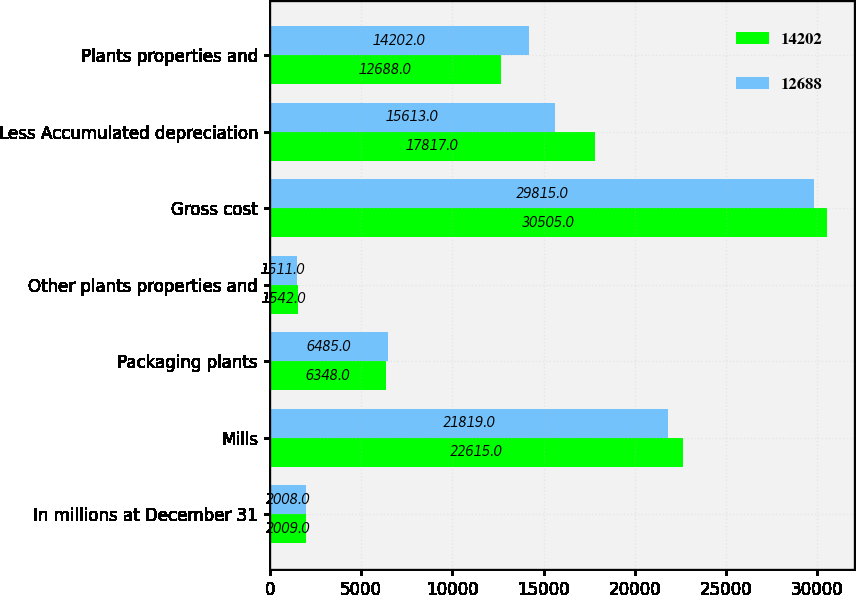Convert chart. <chart><loc_0><loc_0><loc_500><loc_500><stacked_bar_chart><ecel><fcel>In millions at December 31<fcel>Mills<fcel>Packaging plants<fcel>Other plants properties and<fcel>Gross cost<fcel>Less Accumulated depreciation<fcel>Plants properties and<nl><fcel>14202<fcel>2009<fcel>22615<fcel>6348<fcel>1542<fcel>30505<fcel>17817<fcel>12688<nl><fcel>12688<fcel>2008<fcel>21819<fcel>6485<fcel>1511<fcel>29815<fcel>15613<fcel>14202<nl></chart> 